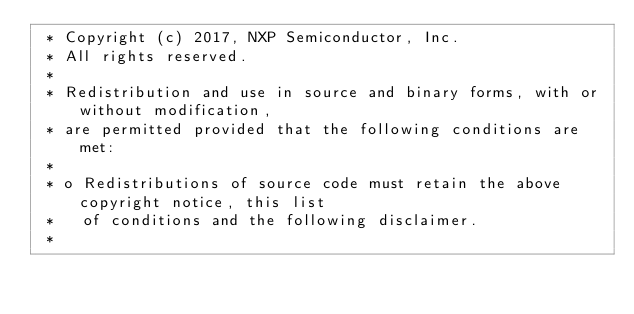<code> <loc_0><loc_0><loc_500><loc_500><_C_> * Copyright (c) 2017, NXP Semiconductor, Inc.
 * All rights reserved.
 *
 * Redistribution and use in source and binary forms, with or without modification,
 * are permitted provided that the following conditions are met:
 *
 * o Redistributions of source code must retain the above copyright notice, this list
 *   of conditions and the following disclaimer.
 *</code> 